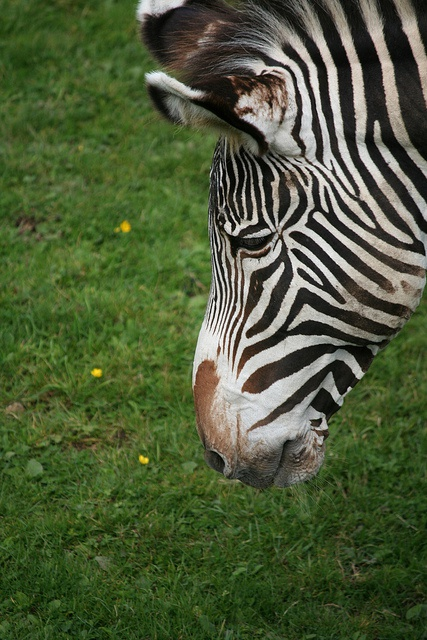Describe the objects in this image and their specific colors. I can see a zebra in darkgreen, black, darkgray, lightgray, and gray tones in this image. 